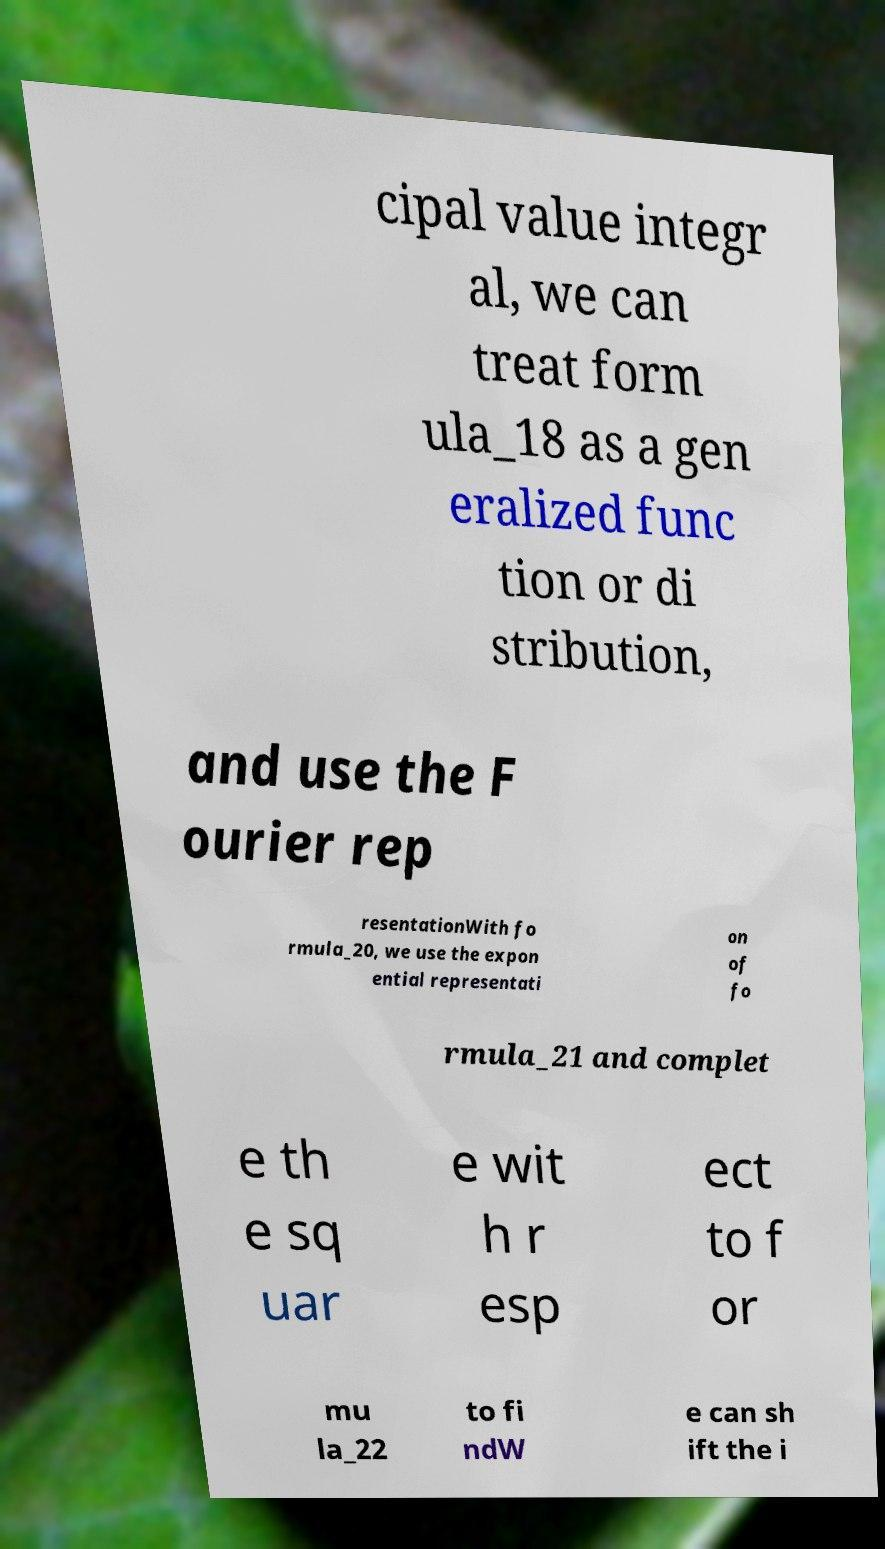I need the written content from this picture converted into text. Can you do that? cipal value integr al, we can treat form ula_18 as a gen eralized func tion or di stribution, and use the F ourier rep resentationWith fo rmula_20, we use the expon ential representati on of fo rmula_21 and complet e th e sq uar e wit h r esp ect to f or mu la_22 to fi ndW e can sh ift the i 